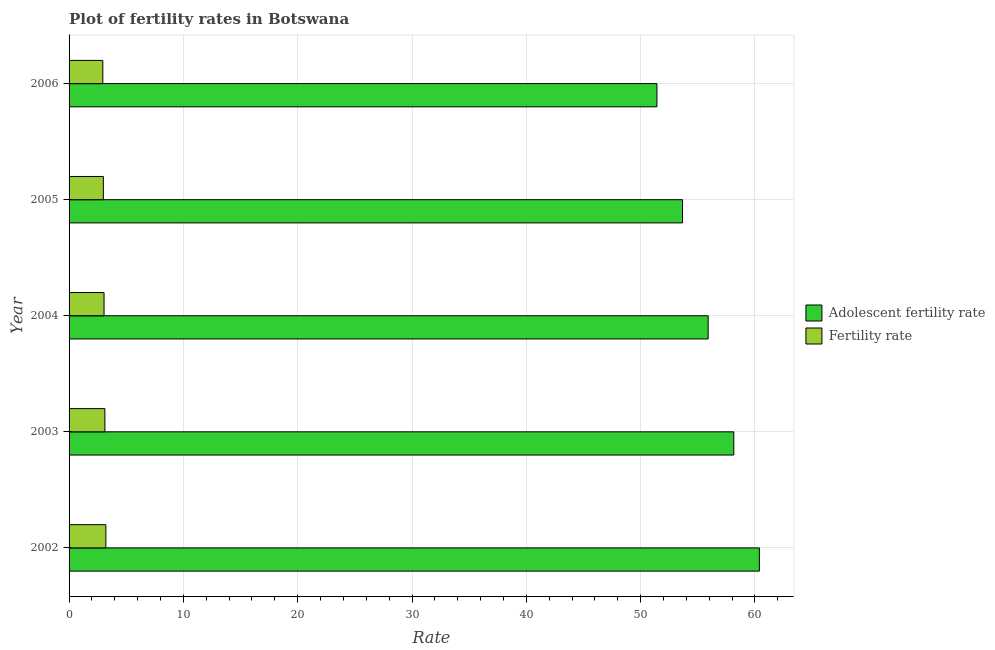How many different coloured bars are there?
Your response must be concise. 2. How many bars are there on the 2nd tick from the top?
Provide a succinct answer. 2. What is the label of the 1st group of bars from the top?
Keep it short and to the point. 2006. In how many cases, is the number of bars for a given year not equal to the number of legend labels?
Your answer should be very brief. 0. What is the fertility rate in 2005?
Offer a terse response. 3. Across all years, what is the maximum adolescent fertility rate?
Your answer should be very brief. 60.39. Across all years, what is the minimum fertility rate?
Your answer should be compact. 2.95. In which year was the fertility rate maximum?
Your response must be concise. 2002. What is the total adolescent fertility rate in the graph?
Ensure brevity in your answer.  279.54. What is the difference between the fertility rate in 2002 and that in 2003?
Your answer should be very brief. 0.09. What is the difference between the adolescent fertility rate in 2004 and the fertility rate in 2003?
Give a very brief answer. 52.77. What is the average fertility rate per year?
Offer a very short reply. 3.07. In the year 2004, what is the difference between the fertility rate and adolescent fertility rate?
Make the answer very short. -52.85. Is the adolescent fertility rate in 2002 less than that in 2005?
Your response must be concise. No. What is the difference between the highest and the second highest fertility rate?
Offer a very short reply. 0.09. What is the difference between the highest and the lowest adolescent fertility rate?
Keep it short and to the point. 8.96. Is the sum of the fertility rate in 2003 and 2004 greater than the maximum adolescent fertility rate across all years?
Provide a short and direct response. No. What does the 1st bar from the top in 2003 represents?
Ensure brevity in your answer.  Fertility rate. What does the 2nd bar from the bottom in 2002 represents?
Offer a very short reply. Fertility rate. What is the difference between two consecutive major ticks on the X-axis?
Your answer should be very brief. 10. Are the values on the major ticks of X-axis written in scientific E-notation?
Make the answer very short. No. Where does the legend appear in the graph?
Make the answer very short. Center right. How are the legend labels stacked?
Offer a very short reply. Vertical. What is the title of the graph?
Make the answer very short. Plot of fertility rates in Botswana. Does "Official aid received" appear as one of the legend labels in the graph?
Your response must be concise. No. What is the label or title of the X-axis?
Give a very brief answer. Rate. What is the Rate of Adolescent fertility rate in 2002?
Offer a terse response. 60.39. What is the Rate of Fertility rate in 2002?
Ensure brevity in your answer.  3.22. What is the Rate in Adolescent fertility rate in 2003?
Make the answer very short. 58.15. What is the Rate in Fertility rate in 2003?
Offer a very short reply. 3.13. What is the Rate of Adolescent fertility rate in 2004?
Your response must be concise. 55.91. What is the Rate of Fertility rate in 2004?
Ensure brevity in your answer.  3.06. What is the Rate of Adolescent fertility rate in 2005?
Offer a terse response. 53.67. What is the Rate of Fertility rate in 2005?
Your answer should be very brief. 3. What is the Rate of Adolescent fertility rate in 2006?
Your answer should be compact. 51.43. What is the Rate in Fertility rate in 2006?
Offer a terse response. 2.95. Across all years, what is the maximum Rate of Adolescent fertility rate?
Your answer should be compact. 60.39. Across all years, what is the maximum Rate of Fertility rate?
Offer a terse response. 3.22. Across all years, what is the minimum Rate in Adolescent fertility rate?
Provide a short and direct response. 51.43. Across all years, what is the minimum Rate of Fertility rate?
Your response must be concise. 2.95. What is the total Rate in Adolescent fertility rate in the graph?
Make the answer very short. 279.54. What is the total Rate of Fertility rate in the graph?
Provide a succinct answer. 15.36. What is the difference between the Rate in Adolescent fertility rate in 2002 and that in 2003?
Offer a terse response. 2.24. What is the difference between the Rate in Fertility rate in 2002 and that in 2003?
Make the answer very short. 0.09. What is the difference between the Rate in Adolescent fertility rate in 2002 and that in 2004?
Offer a terse response. 4.48. What is the difference between the Rate in Fertility rate in 2002 and that in 2004?
Ensure brevity in your answer.  0.16. What is the difference between the Rate of Adolescent fertility rate in 2002 and that in 2005?
Offer a terse response. 6.72. What is the difference between the Rate in Fertility rate in 2002 and that in 2005?
Provide a short and direct response. 0.22. What is the difference between the Rate of Adolescent fertility rate in 2002 and that in 2006?
Keep it short and to the point. 8.96. What is the difference between the Rate of Fertility rate in 2002 and that in 2006?
Your response must be concise. 0.27. What is the difference between the Rate in Adolescent fertility rate in 2003 and that in 2004?
Your answer should be very brief. 2.24. What is the difference between the Rate in Fertility rate in 2003 and that in 2004?
Your answer should be very brief. 0.07. What is the difference between the Rate of Adolescent fertility rate in 2003 and that in 2005?
Keep it short and to the point. 4.48. What is the difference between the Rate of Fertility rate in 2003 and that in 2005?
Offer a terse response. 0.14. What is the difference between the Rate of Adolescent fertility rate in 2003 and that in 2006?
Your answer should be compact. 6.72. What is the difference between the Rate of Fertility rate in 2003 and that in 2006?
Your answer should be very brief. 0.18. What is the difference between the Rate of Adolescent fertility rate in 2004 and that in 2005?
Give a very brief answer. 2.24. What is the difference between the Rate in Fertility rate in 2004 and that in 2005?
Your response must be concise. 0.06. What is the difference between the Rate in Adolescent fertility rate in 2004 and that in 2006?
Offer a terse response. 4.48. What is the difference between the Rate in Fertility rate in 2004 and that in 2006?
Ensure brevity in your answer.  0.11. What is the difference between the Rate of Adolescent fertility rate in 2005 and that in 2006?
Ensure brevity in your answer.  2.24. What is the difference between the Rate of Fertility rate in 2005 and that in 2006?
Provide a short and direct response. 0.05. What is the difference between the Rate in Adolescent fertility rate in 2002 and the Rate in Fertility rate in 2003?
Keep it short and to the point. 57.26. What is the difference between the Rate of Adolescent fertility rate in 2002 and the Rate of Fertility rate in 2004?
Offer a very short reply. 57.33. What is the difference between the Rate in Adolescent fertility rate in 2002 and the Rate in Fertility rate in 2005?
Your answer should be compact. 57.39. What is the difference between the Rate in Adolescent fertility rate in 2002 and the Rate in Fertility rate in 2006?
Provide a short and direct response. 57.44. What is the difference between the Rate of Adolescent fertility rate in 2003 and the Rate of Fertility rate in 2004?
Your response must be concise. 55.09. What is the difference between the Rate of Adolescent fertility rate in 2003 and the Rate of Fertility rate in 2005?
Keep it short and to the point. 55.15. What is the difference between the Rate in Adolescent fertility rate in 2003 and the Rate in Fertility rate in 2006?
Give a very brief answer. 55.2. What is the difference between the Rate of Adolescent fertility rate in 2004 and the Rate of Fertility rate in 2005?
Your answer should be compact. 52.91. What is the difference between the Rate of Adolescent fertility rate in 2004 and the Rate of Fertility rate in 2006?
Offer a very short reply. 52.96. What is the difference between the Rate of Adolescent fertility rate in 2005 and the Rate of Fertility rate in 2006?
Offer a terse response. 50.71. What is the average Rate in Adolescent fertility rate per year?
Provide a succinct answer. 55.91. What is the average Rate of Fertility rate per year?
Keep it short and to the point. 3.07. In the year 2002, what is the difference between the Rate of Adolescent fertility rate and Rate of Fertility rate?
Offer a very short reply. 57.17. In the year 2003, what is the difference between the Rate in Adolescent fertility rate and Rate in Fertility rate?
Provide a succinct answer. 55.01. In the year 2004, what is the difference between the Rate of Adolescent fertility rate and Rate of Fertility rate?
Your answer should be very brief. 52.85. In the year 2005, what is the difference between the Rate of Adolescent fertility rate and Rate of Fertility rate?
Make the answer very short. 50.67. In the year 2006, what is the difference between the Rate in Adolescent fertility rate and Rate in Fertility rate?
Keep it short and to the point. 48.47. What is the ratio of the Rate of Fertility rate in 2002 to that in 2003?
Keep it short and to the point. 1.03. What is the ratio of the Rate in Adolescent fertility rate in 2002 to that in 2004?
Offer a very short reply. 1.08. What is the ratio of the Rate in Fertility rate in 2002 to that in 2004?
Offer a terse response. 1.05. What is the ratio of the Rate of Adolescent fertility rate in 2002 to that in 2005?
Your response must be concise. 1.13. What is the ratio of the Rate in Fertility rate in 2002 to that in 2005?
Provide a short and direct response. 1.07. What is the ratio of the Rate of Adolescent fertility rate in 2002 to that in 2006?
Your response must be concise. 1.17. What is the ratio of the Rate of Fertility rate in 2002 to that in 2006?
Give a very brief answer. 1.09. What is the ratio of the Rate in Adolescent fertility rate in 2003 to that in 2004?
Your answer should be very brief. 1.04. What is the ratio of the Rate in Fertility rate in 2003 to that in 2004?
Provide a short and direct response. 1.02. What is the ratio of the Rate of Adolescent fertility rate in 2003 to that in 2005?
Give a very brief answer. 1.08. What is the ratio of the Rate of Fertility rate in 2003 to that in 2005?
Offer a terse response. 1.05. What is the ratio of the Rate in Adolescent fertility rate in 2003 to that in 2006?
Your answer should be compact. 1.13. What is the ratio of the Rate in Fertility rate in 2003 to that in 2006?
Offer a very short reply. 1.06. What is the ratio of the Rate in Adolescent fertility rate in 2004 to that in 2005?
Ensure brevity in your answer.  1.04. What is the ratio of the Rate in Fertility rate in 2004 to that in 2005?
Make the answer very short. 1.02. What is the ratio of the Rate of Adolescent fertility rate in 2004 to that in 2006?
Keep it short and to the point. 1.09. What is the ratio of the Rate in Fertility rate in 2004 to that in 2006?
Offer a terse response. 1.04. What is the ratio of the Rate in Adolescent fertility rate in 2005 to that in 2006?
Your answer should be compact. 1.04. What is the ratio of the Rate in Fertility rate in 2005 to that in 2006?
Provide a short and direct response. 1.02. What is the difference between the highest and the second highest Rate in Adolescent fertility rate?
Keep it short and to the point. 2.24. What is the difference between the highest and the second highest Rate in Fertility rate?
Your answer should be very brief. 0.09. What is the difference between the highest and the lowest Rate in Adolescent fertility rate?
Offer a terse response. 8.96. What is the difference between the highest and the lowest Rate of Fertility rate?
Keep it short and to the point. 0.27. 